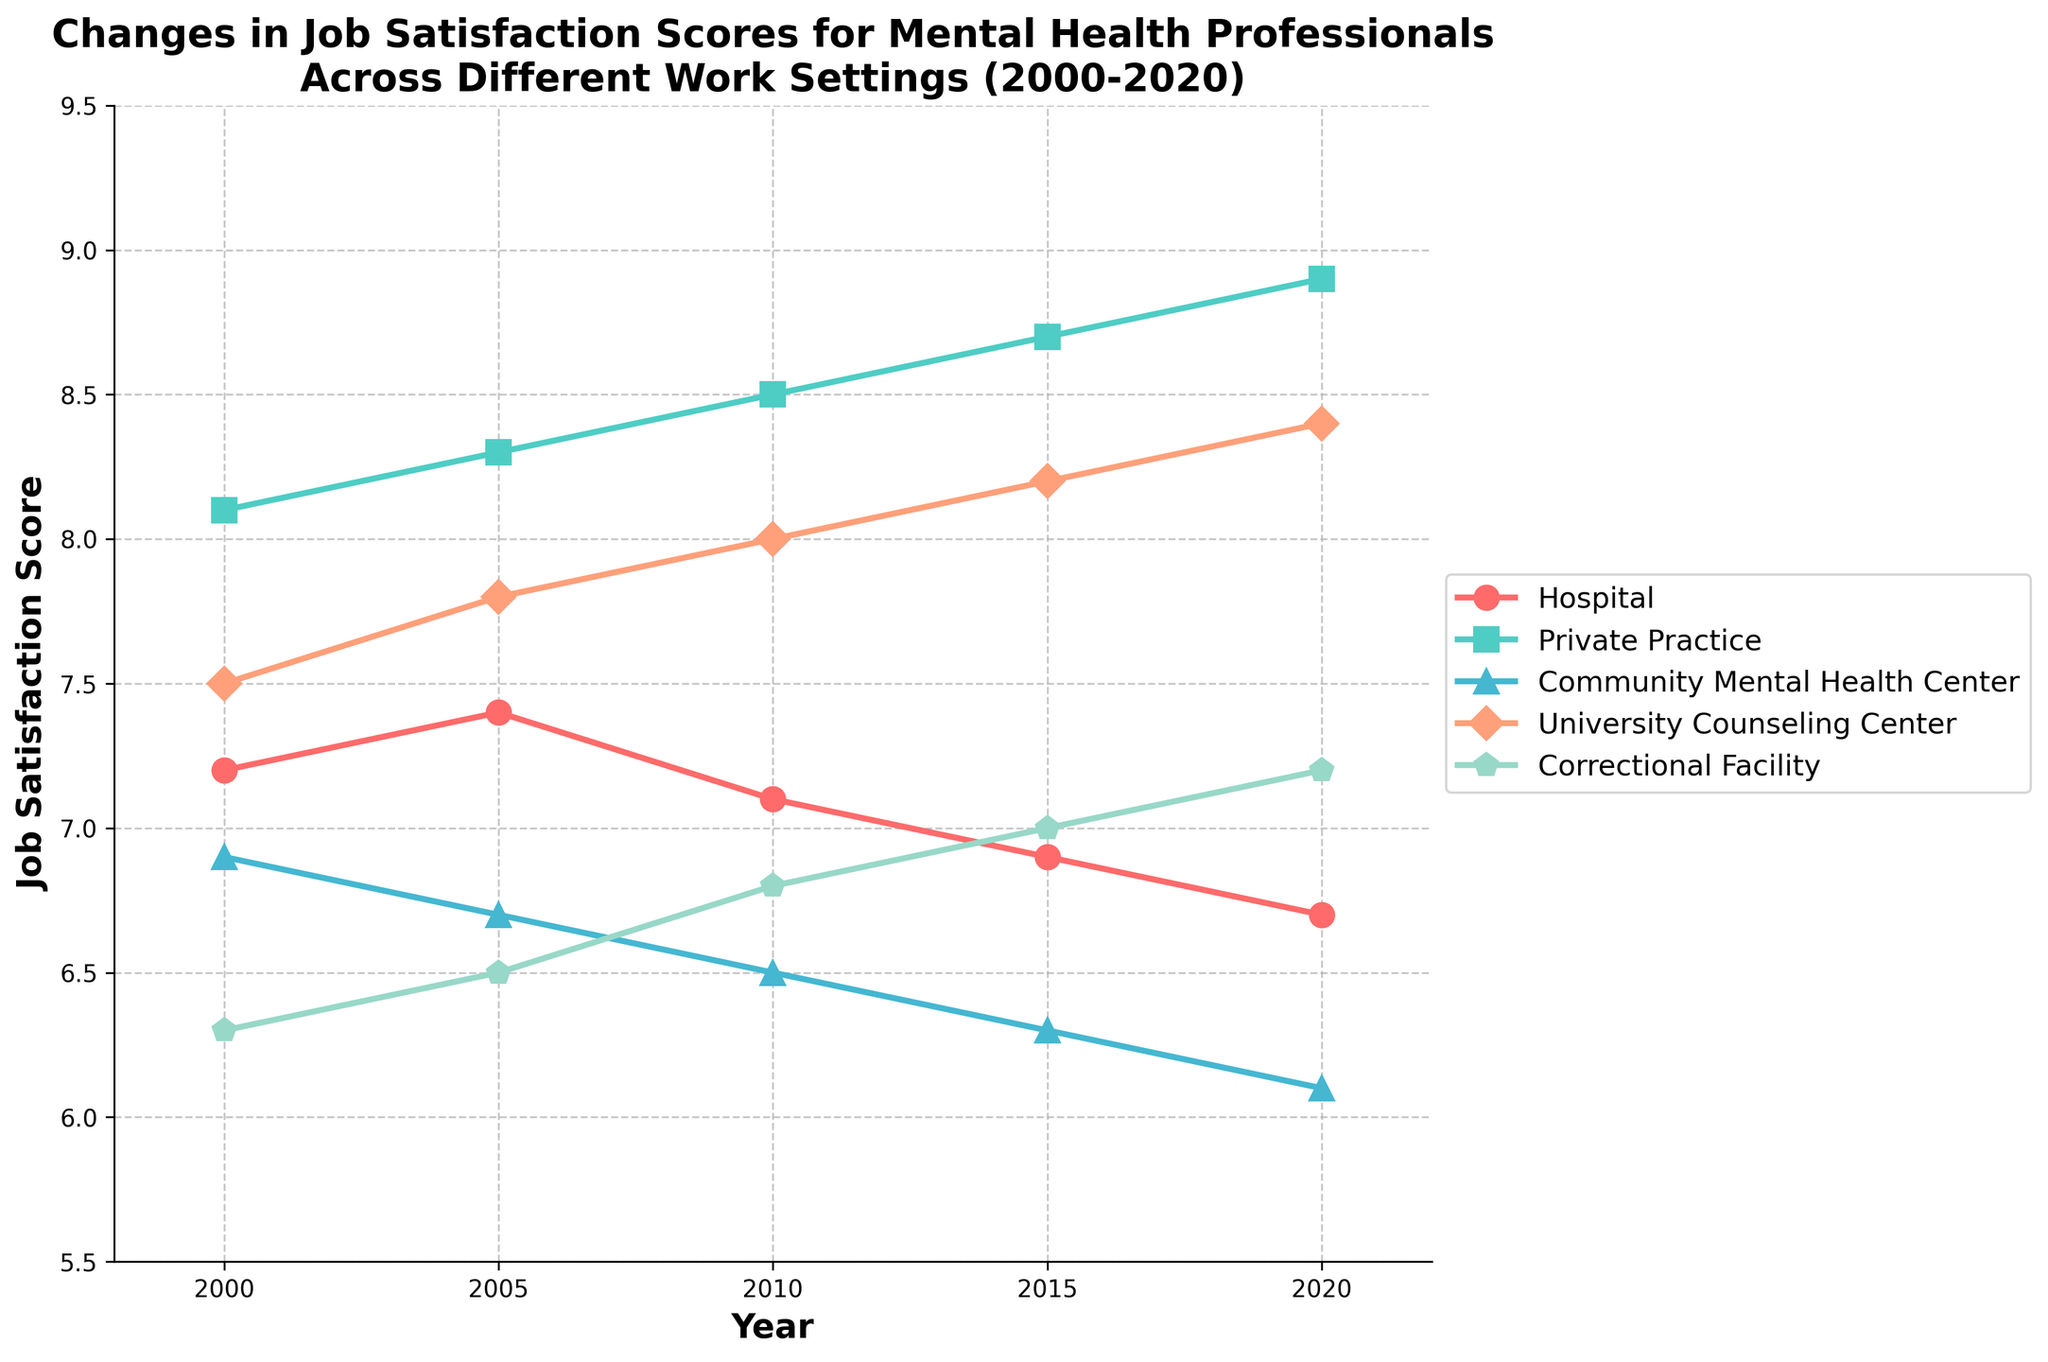What's the trend in job satisfaction scores for hospital workers over the 20-year period? To identify the trend, look at the line representing hospital workers from 2000 to 2020. It starts at 7.2 in 2000 and decreases to 6.7 by 2020. Thus, the trend is a gradual decline.
Answer: Gradual decline In which work setting did the job satisfaction increase the most from 2000 to 2020? Check the starting (2000) and ending (2020) points for each work setting. Private Practice increased from 8.1 to 8.9, making it the work setting with the highest increase of 0.8 points.
Answer: Private Practice Which work setting had the lowest job satisfaction score in 2020? Look at the data points for 2020 across all work settings. The Community Mental Health Center had a score of 6.1, which is the lowest among all.
Answer: Community Mental Health Center How did the job satisfaction score for the University Counseling Center change between 2005 and 2015? Note the scores for the University Counseling Center in 2005 and 2015. It increased from 7.8 in 2005 to 8.2 in 2015, indicating an increase of 0.4 points.
Answer: Increased by 0.4 points What is the average job satisfaction score for Correctional Facility workers over the 20 years? Add the scores for Correctional Facility for all the years: 6.3 + 6.5 + 6.8 + 7.0 + 7.2 and divide by the number of years (5). The average is (6.3 + 6.5 + 6.8 + 7.0 + 7.2) / 5 = 6.76.
Answer: 6.76 Compare the job satisfaction scores for Community Mental Health Center and Correctional Facility in 2010. Which one is higher? Look at the scores for both settings in 2010. Community Mental Health Center is 6.5 and Correctional Facility is 6.8. 6.8 is higher than 6.5.
Answer: Correctional Facility What year did the University Counseling Center's job satisfaction score surpass 8 for the first time? Identify the year when the line for the University Counseling Center first crosses 8. This occurred in 2010.
Answer: 2010 Which work setting has the most consistent job satisfaction scores over time? Evaluate the stability of all lines over time. The Private Practice line shows a consistent upward trend without sudden drops or spikes.
Answer: Private Practice What's the difference in job satisfaction scores between Private Practice and Hospital in 2020? Find the scores for both work settings in 2020. Private Practice is 8.9 and Hospital is 6.7. The difference is 8.9 - 6.7 = 2.2.
Answer: 2.2 